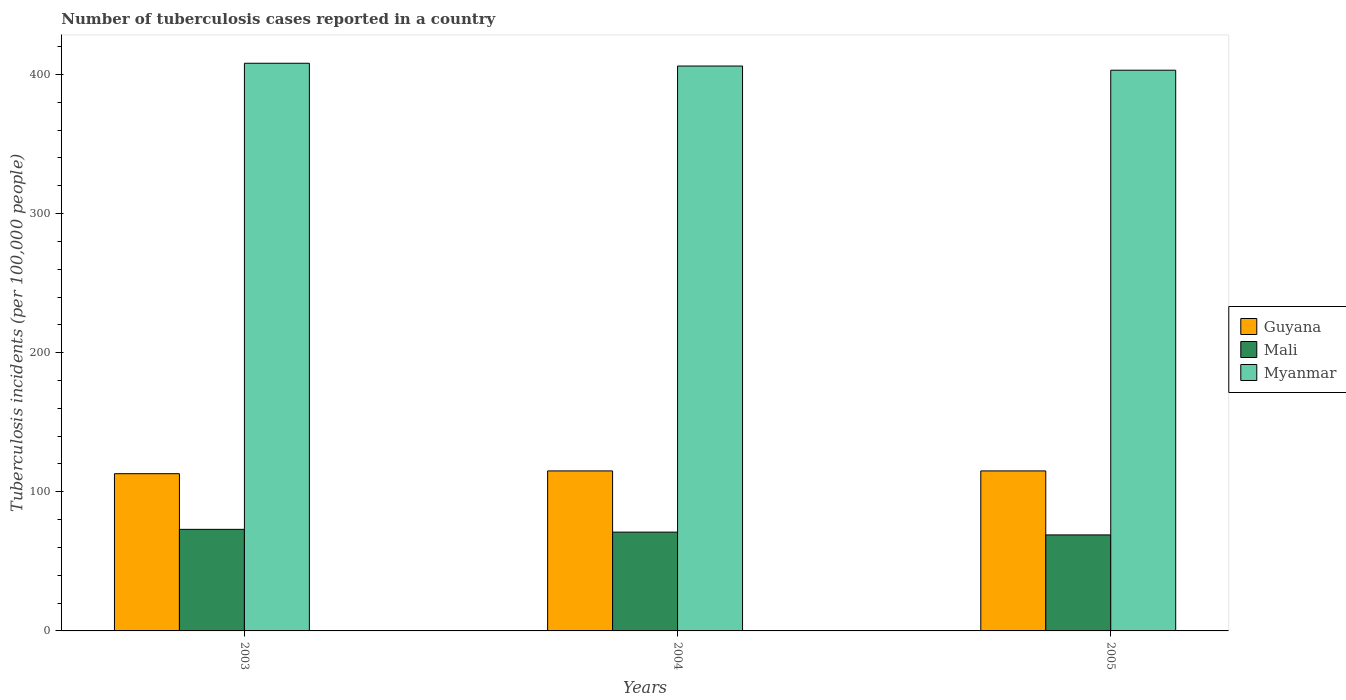How many groups of bars are there?
Offer a terse response. 3. Are the number of bars per tick equal to the number of legend labels?
Provide a succinct answer. Yes. Are the number of bars on each tick of the X-axis equal?
Your answer should be very brief. Yes. How many bars are there on the 3rd tick from the left?
Make the answer very short. 3. What is the label of the 1st group of bars from the left?
Give a very brief answer. 2003. In how many cases, is the number of bars for a given year not equal to the number of legend labels?
Give a very brief answer. 0. What is the number of tuberculosis cases reported in in Myanmar in 2004?
Your answer should be compact. 406. Across all years, what is the maximum number of tuberculosis cases reported in in Mali?
Your answer should be compact. 73. Across all years, what is the minimum number of tuberculosis cases reported in in Mali?
Keep it short and to the point. 69. In which year was the number of tuberculosis cases reported in in Guyana maximum?
Your response must be concise. 2004. What is the total number of tuberculosis cases reported in in Guyana in the graph?
Give a very brief answer. 343. What is the difference between the number of tuberculosis cases reported in in Mali in 2003 and that in 2004?
Make the answer very short. 2. What is the difference between the number of tuberculosis cases reported in in Guyana in 2005 and the number of tuberculosis cases reported in in Myanmar in 2004?
Provide a succinct answer. -291. What is the average number of tuberculosis cases reported in in Myanmar per year?
Offer a terse response. 405.67. In the year 2003, what is the difference between the number of tuberculosis cases reported in in Myanmar and number of tuberculosis cases reported in in Guyana?
Your answer should be very brief. 295. In how many years, is the number of tuberculosis cases reported in in Mali greater than 120?
Offer a terse response. 0. What is the ratio of the number of tuberculosis cases reported in in Guyana in 2003 to that in 2004?
Ensure brevity in your answer.  0.98. Is the number of tuberculosis cases reported in in Guyana in 2003 less than that in 2004?
Your answer should be very brief. Yes. Is the difference between the number of tuberculosis cases reported in in Myanmar in 2003 and 2005 greater than the difference between the number of tuberculosis cases reported in in Guyana in 2003 and 2005?
Provide a succinct answer. Yes. What is the difference between the highest and the second highest number of tuberculosis cases reported in in Guyana?
Ensure brevity in your answer.  0. What is the difference between the highest and the lowest number of tuberculosis cases reported in in Guyana?
Ensure brevity in your answer.  2. In how many years, is the number of tuberculosis cases reported in in Guyana greater than the average number of tuberculosis cases reported in in Guyana taken over all years?
Offer a terse response. 2. Is the sum of the number of tuberculosis cases reported in in Mali in 2003 and 2004 greater than the maximum number of tuberculosis cases reported in in Myanmar across all years?
Offer a terse response. No. What does the 2nd bar from the left in 2003 represents?
Your answer should be compact. Mali. What does the 2nd bar from the right in 2005 represents?
Give a very brief answer. Mali. What is the difference between two consecutive major ticks on the Y-axis?
Your answer should be very brief. 100. Does the graph contain grids?
Your answer should be very brief. No. How are the legend labels stacked?
Offer a terse response. Vertical. What is the title of the graph?
Offer a very short reply. Number of tuberculosis cases reported in a country. What is the label or title of the X-axis?
Keep it short and to the point. Years. What is the label or title of the Y-axis?
Offer a terse response. Tuberculosis incidents (per 100,0 people). What is the Tuberculosis incidents (per 100,000 people) of Guyana in 2003?
Offer a terse response. 113. What is the Tuberculosis incidents (per 100,000 people) of Myanmar in 2003?
Your response must be concise. 408. What is the Tuberculosis incidents (per 100,000 people) of Guyana in 2004?
Give a very brief answer. 115. What is the Tuberculosis incidents (per 100,000 people) in Myanmar in 2004?
Your answer should be very brief. 406. What is the Tuberculosis incidents (per 100,000 people) in Guyana in 2005?
Keep it short and to the point. 115. What is the Tuberculosis incidents (per 100,000 people) in Mali in 2005?
Your response must be concise. 69. What is the Tuberculosis incidents (per 100,000 people) of Myanmar in 2005?
Provide a short and direct response. 403. Across all years, what is the maximum Tuberculosis incidents (per 100,000 people) of Guyana?
Give a very brief answer. 115. Across all years, what is the maximum Tuberculosis incidents (per 100,000 people) of Mali?
Offer a very short reply. 73. Across all years, what is the maximum Tuberculosis incidents (per 100,000 people) of Myanmar?
Your response must be concise. 408. Across all years, what is the minimum Tuberculosis incidents (per 100,000 people) in Guyana?
Give a very brief answer. 113. Across all years, what is the minimum Tuberculosis incidents (per 100,000 people) of Mali?
Offer a terse response. 69. Across all years, what is the minimum Tuberculosis incidents (per 100,000 people) in Myanmar?
Ensure brevity in your answer.  403. What is the total Tuberculosis incidents (per 100,000 people) in Guyana in the graph?
Your answer should be very brief. 343. What is the total Tuberculosis incidents (per 100,000 people) of Mali in the graph?
Offer a very short reply. 213. What is the total Tuberculosis incidents (per 100,000 people) in Myanmar in the graph?
Keep it short and to the point. 1217. What is the difference between the Tuberculosis incidents (per 100,000 people) of Guyana in 2003 and that in 2004?
Make the answer very short. -2. What is the difference between the Tuberculosis incidents (per 100,000 people) in Myanmar in 2003 and that in 2004?
Give a very brief answer. 2. What is the difference between the Tuberculosis incidents (per 100,000 people) in Guyana in 2003 and that in 2005?
Offer a very short reply. -2. What is the difference between the Tuberculosis incidents (per 100,000 people) in Mali in 2003 and that in 2005?
Make the answer very short. 4. What is the difference between the Tuberculosis incidents (per 100,000 people) of Guyana in 2004 and that in 2005?
Provide a short and direct response. 0. What is the difference between the Tuberculosis incidents (per 100,000 people) in Mali in 2004 and that in 2005?
Your answer should be compact. 2. What is the difference between the Tuberculosis incidents (per 100,000 people) in Guyana in 2003 and the Tuberculosis incidents (per 100,000 people) in Mali in 2004?
Give a very brief answer. 42. What is the difference between the Tuberculosis incidents (per 100,000 people) in Guyana in 2003 and the Tuberculosis incidents (per 100,000 people) in Myanmar in 2004?
Offer a very short reply. -293. What is the difference between the Tuberculosis incidents (per 100,000 people) in Mali in 2003 and the Tuberculosis incidents (per 100,000 people) in Myanmar in 2004?
Keep it short and to the point. -333. What is the difference between the Tuberculosis incidents (per 100,000 people) of Guyana in 2003 and the Tuberculosis incidents (per 100,000 people) of Mali in 2005?
Offer a terse response. 44. What is the difference between the Tuberculosis incidents (per 100,000 people) of Guyana in 2003 and the Tuberculosis incidents (per 100,000 people) of Myanmar in 2005?
Provide a short and direct response. -290. What is the difference between the Tuberculosis incidents (per 100,000 people) in Mali in 2003 and the Tuberculosis incidents (per 100,000 people) in Myanmar in 2005?
Make the answer very short. -330. What is the difference between the Tuberculosis incidents (per 100,000 people) of Guyana in 2004 and the Tuberculosis incidents (per 100,000 people) of Mali in 2005?
Ensure brevity in your answer.  46. What is the difference between the Tuberculosis incidents (per 100,000 people) of Guyana in 2004 and the Tuberculosis incidents (per 100,000 people) of Myanmar in 2005?
Keep it short and to the point. -288. What is the difference between the Tuberculosis incidents (per 100,000 people) of Mali in 2004 and the Tuberculosis incidents (per 100,000 people) of Myanmar in 2005?
Your response must be concise. -332. What is the average Tuberculosis incidents (per 100,000 people) of Guyana per year?
Make the answer very short. 114.33. What is the average Tuberculosis incidents (per 100,000 people) of Myanmar per year?
Your answer should be compact. 405.67. In the year 2003, what is the difference between the Tuberculosis incidents (per 100,000 people) in Guyana and Tuberculosis incidents (per 100,000 people) in Mali?
Provide a short and direct response. 40. In the year 2003, what is the difference between the Tuberculosis incidents (per 100,000 people) of Guyana and Tuberculosis incidents (per 100,000 people) of Myanmar?
Make the answer very short. -295. In the year 2003, what is the difference between the Tuberculosis incidents (per 100,000 people) of Mali and Tuberculosis incidents (per 100,000 people) of Myanmar?
Make the answer very short. -335. In the year 2004, what is the difference between the Tuberculosis incidents (per 100,000 people) of Guyana and Tuberculosis incidents (per 100,000 people) of Mali?
Offer a terse response. 44. In the year 2004, what is the difference between the Tuberculosis incidents (per 100,000 people) of Guyana and Tuberculosis incidents (per 100,000 people) of Myanmar?
Offer a very short reply. -291. In the year 2004, what is the difference between the Tuberculosis incidents (per 100,000 people) of Mali and Tuberculosis incidents (per 100,000 people) of Myanmar?
Keep it short and to the point. -335. In the year 2005, what is the difference between the Tuberculosis incidents (per 100,000 people) in Guyana and Tuberculosis incidents (per 100,000 people) in Myanmar?
Give a very brief answer. -288. In the year 2005, what is the difference between the Tuberculosis incidents (per 100,000 people) in Mali and Tuberculosis incidents (per 100,000 people) in Myanmar?
Ensure brevity in your answer.  -334. What is the ratio of the Tuberculosis incidents (per 100,000 people) of Guyana in 2003 to that in 2004?
Keep it short and to the point. 0.98. What is the ratio of the Tuberculosis incidents (per 100,000 people) of Mali in 2003 to that in 2004?
Give a very brief answer. 1.03. What is the ratio of the Tuberculosis incidents (per 100,000 people) in Myanmar in 2003 to that in 2004?
Offer a very short reply. 1. What is the ratio of the Tuberculosis incidents (per 100,000 people) of Guyana in 2003 to that in 2005?
Keep it short and to the point. 0.98. What is the ratio of the Tuberculosis incidents (per 100,000 people) of Mali in 2003 to that in 2005?
Your answer should be very brief. 1.06. What is the ratio of the Tuberculosis incidents (per 100,000 people) in Myanmar in 2003 to that in 2005?
Your answer should be very brief. 1.01. What is the ratio of the Tuberculosis incidents (per 100,000 people) in Guyana in 2004 to that in 2005?
Keep it short and to the point. 1. What is the ratio of the Tuberculosis incidents (per 100,000 people) of Myanmar in 2004 to that in 2005?
Your response must be concise. 1.01. What is the difference between the highest and the second highest Tuberculosis incidents (per 100,000 people) of Guyana?
Your answer should be compact. 0. What is the difference between the highest and the second highest Tuberculosis incidents (per 100,000 people) of Myanmar?
Offer a very short reply. 2. What is the difference between the highest and the lowest Tuberculosis incidents (per 100,000 people) of Mali?
Make the answer very short. 4. What is the difference between the highest and the lowest Tuberculosis incidents (per 100,000 people) of Myanmar?
Offer a very short reply. 5. 